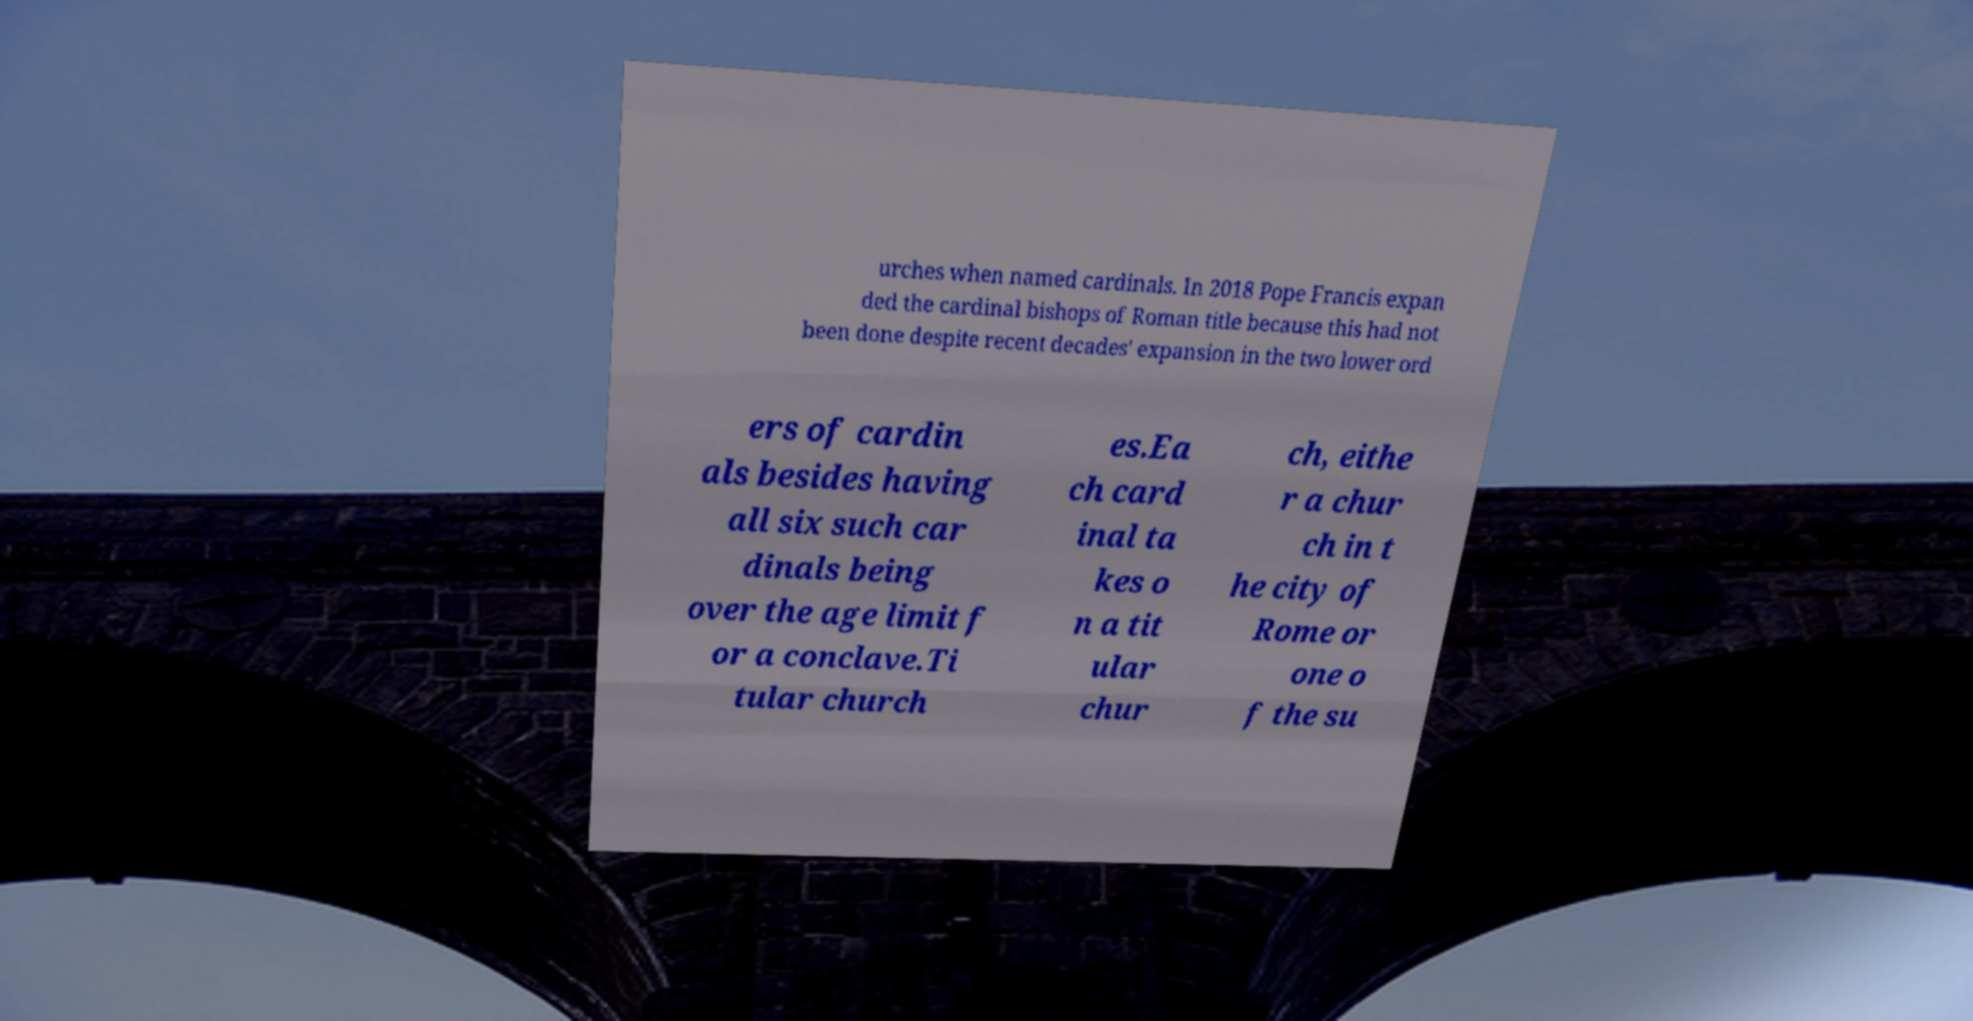What messages or text are displayed in this image? I need them in a readable, typed format. urches when named cardinals. In 2018 Pope Francis expan ded the cardinal bishops of Roman title because this had not been done despite recent decades' expansion in the two lower ord ers of cardin als besides having all six such car dinals being over the age limit f or a conclave.Ti tular church es.Ea ch card inal ta kes o n a tit ular chur ch, eithe r a chur ch in t he city of Rome or one o f the su 